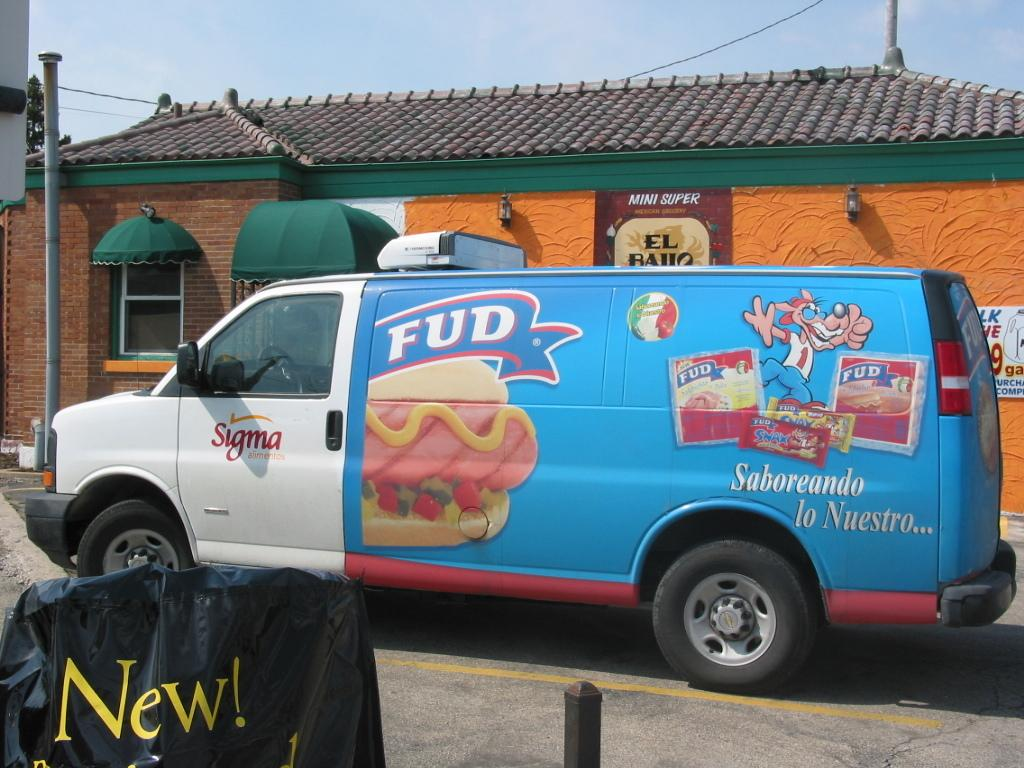<image>
Offer a succinct explanation of the picture presented. The delivery truck logo says FUD and it is blue. 